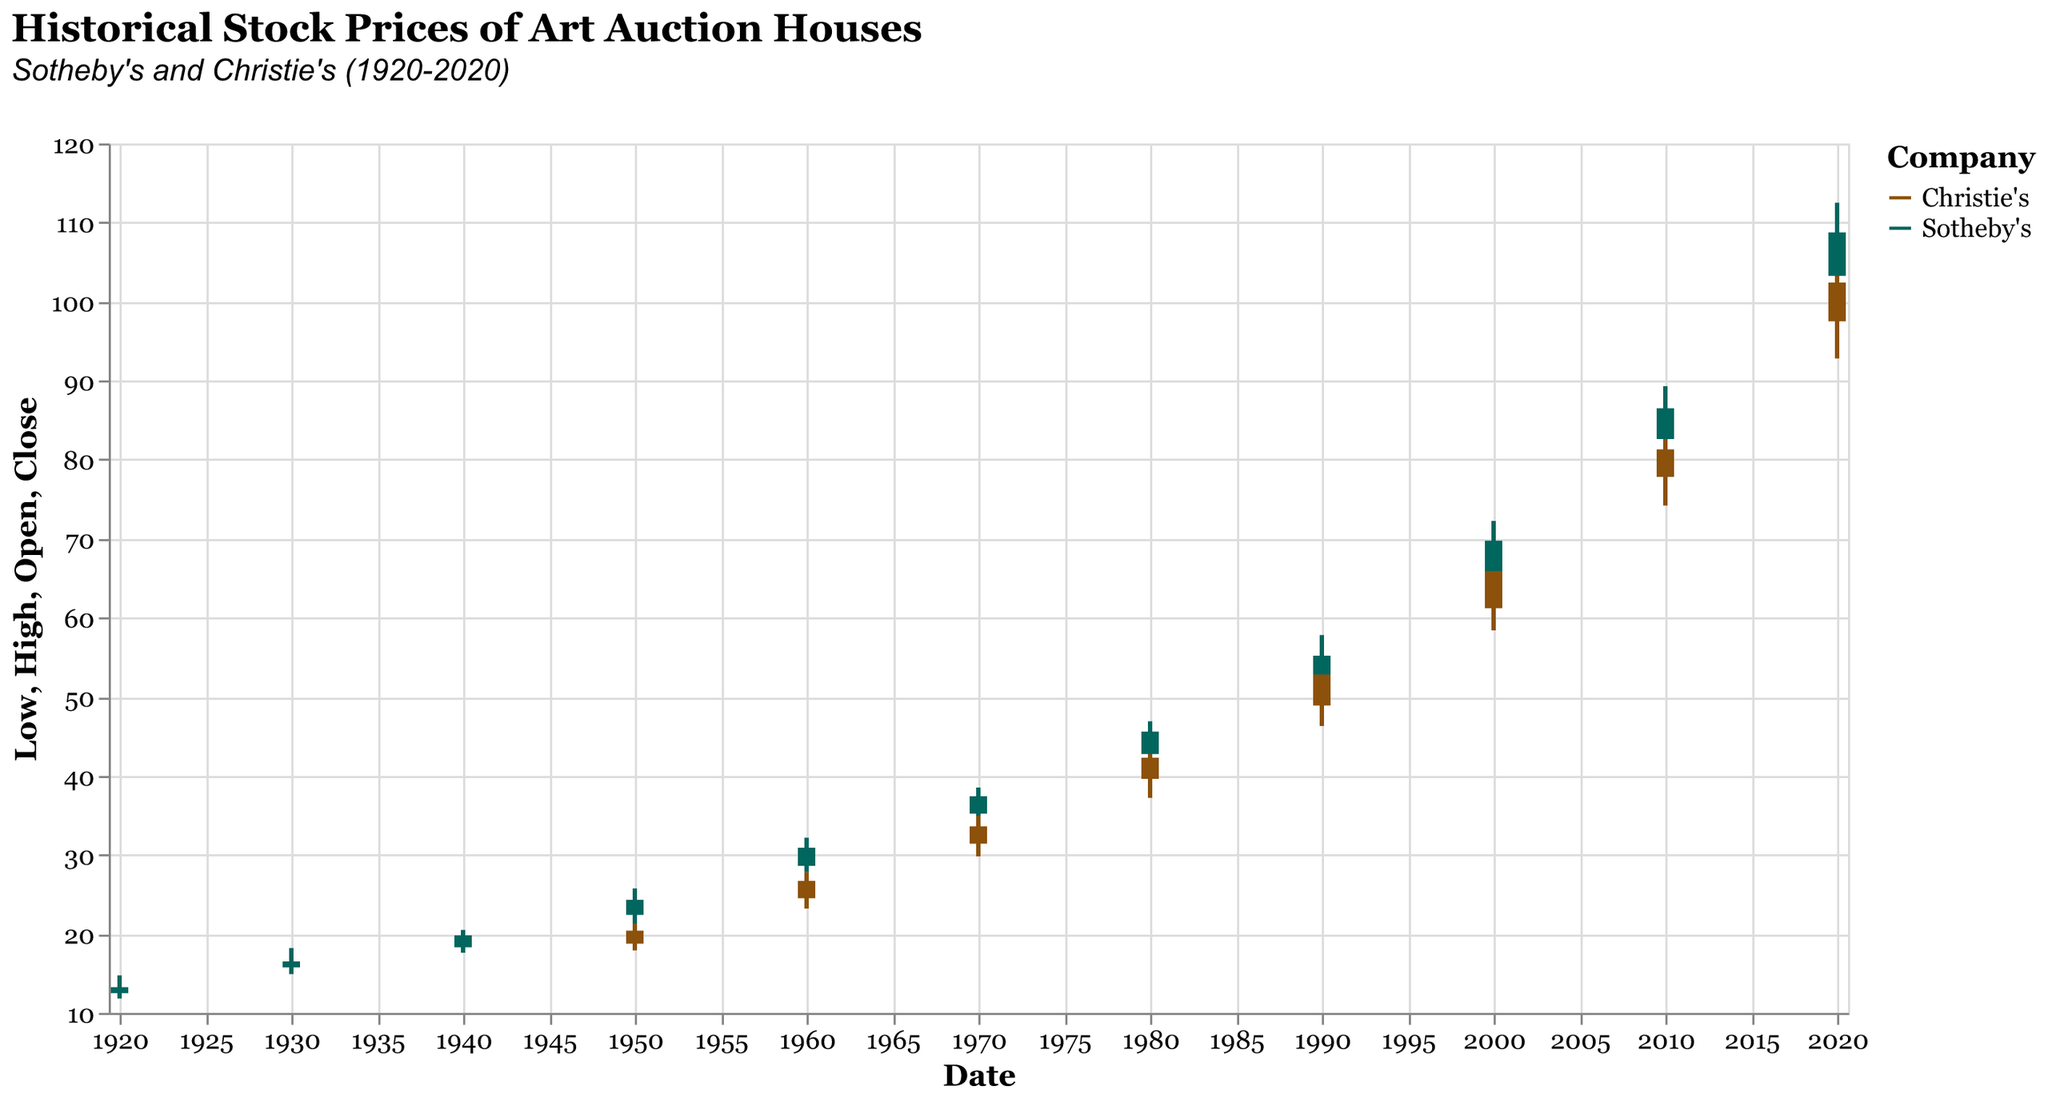What is the highest stock price of Sotheby's in 2020? Look at the data point for Sotheby's in 2020 and identify the value in the 'High' field.
Answer: 112.50 Which company had a higher closing stock price in 2010? Compare the closing prices of Sotheby's and Christie's in the year 2010. Sotheby's closed at 86.50, and Christie's closed at 81.30.
Answer: Sotheby's How did Sotheby's stock price change from 1930 to 1940? Find the closing prices of Sotheby's in 1930 (16.50) and 1940 (19.80) and subtract the former from the latter.
Answer: Increased by 3.30 What was the average closing stock price of Christie's over the last three decades? Identify the closing prices of Christie's in 1990 (52.80), 2000 (65.90), 2010 (81.30), and 2020 (102.40). Add these values and divide by the number of data points (4).
Answer: 75.60 Which year saw the biggest difference between the highest and lowest prices for Christie's? Calculate the differences between the 'High' and 'Low' prices for each year for Christie's. The differences are 3.4 (1950), 4.6 (1960), 5.1 (1970), 6.55 (1980), 7.95 (1990), 9.1 (2000), 10.4 (2010), and 13.95 (2020).
Answer: 2020 Did Christie's or Sotheby's have a higher opening price in 1950? Compare the opening prices of Christie's (18.75) and Sotheby's (22.40) in 1950.
Answer: Sotheby's What is the trend of the closing prices of Sotheby's from 1920 to 2020? Analyze the closing prices from each decade for Sotheby's: 1920 (13.25), 1930 (16.50), 1940 (19.80), 1950 (24.30), 1960 (30.90), 1970 (37.40), 1980 (45.60), 1990 (55.20), 2000 (69.75), 2010 (86.50), 2020 (108.75). The trend shows a consistent increase over time.
Answer: Increasing trend Between 1930 and 1940, which company's stock saw a larger percentage increase in its closing price? Calculate the percentage increase for both companies:
 - Sotheby's: ((19.80 - 16.50) / 16.50) * 100 ≈ 20%
 - Christie's: Closed at 20.40 in 1950, but no data from 1930 or 1940 provided
Answer: Sotheby's What is the color assigned to Sotheby's in the chart? Look for the color used for the line and bars representing Sotheby's.
Answer: Brown Which year had the lowest opening price for Sotheby's? Look at the 'Open' prices for each year available for Sotheby's and identify the minimum value.
Answer: 1920 